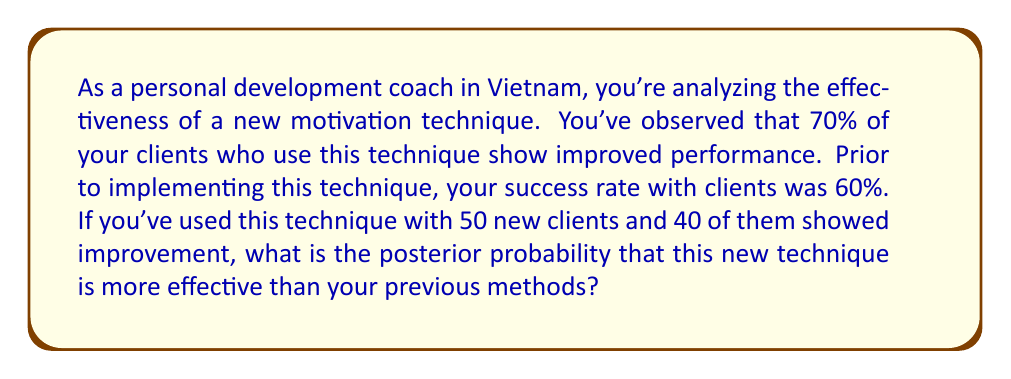Can you answer this question? To solve this problem, we'll use Bayesian inference. Let's break it down step by step:

1) Define our hypothesis:
   H: The new technique is more effective than previous methods

2) Prior probability:
   P(H) = 0.5 (we start with a neutral prior)

3) Likelihood:
   P(D|H) = probability of observing the data given the hypothesis is true
   P(D|H) = $\binom{50}{40} \cdot 0.7^{40} \cdot 0.3^{10}$

4) Alternative hypothesis:
   Not H: The new technique is not more effective
   P(D|not H) = $\binom{50}{40} \cdot 0.6^{40} \cdot 0.4^{10}$

5) Calculate the posterior probability using Bayes' theorem:

   $$P(H|D) = \frac{P(D|H) \cdot P(H)}{P(D|H) \cdot P(H) + P(D|not H) \cdot P(not H)}$$

6) Plug in the values:

   $$P(H|D) = \frac{\binom{50}{40} \cdot 0.7^{40} \cdot 0.3^{10} \cdot 0.5}{\binom{50}{40} \cdot 0.7^{40} \cdot 0.3^{10} \cdot 0.5 + \binom{50}{40} \cdot 0.6^{40} \cdot 0.4^{10} \cdot 0.5}$$

7) Simplify:

   $$P(H|D) = \frac{0.7^{40} \cdot 0.3^{10}}{0.7^{40} \cdot 0.3^{10} + 0.6^{40} \cdot 0.4^{10}}$$

8) Calculate:

   $$P(H|D) \approx 0.9997$$
Answer: The posterior probability that the new technique is more effective than previous methods is approximately 0.9997 or 99.97%. 